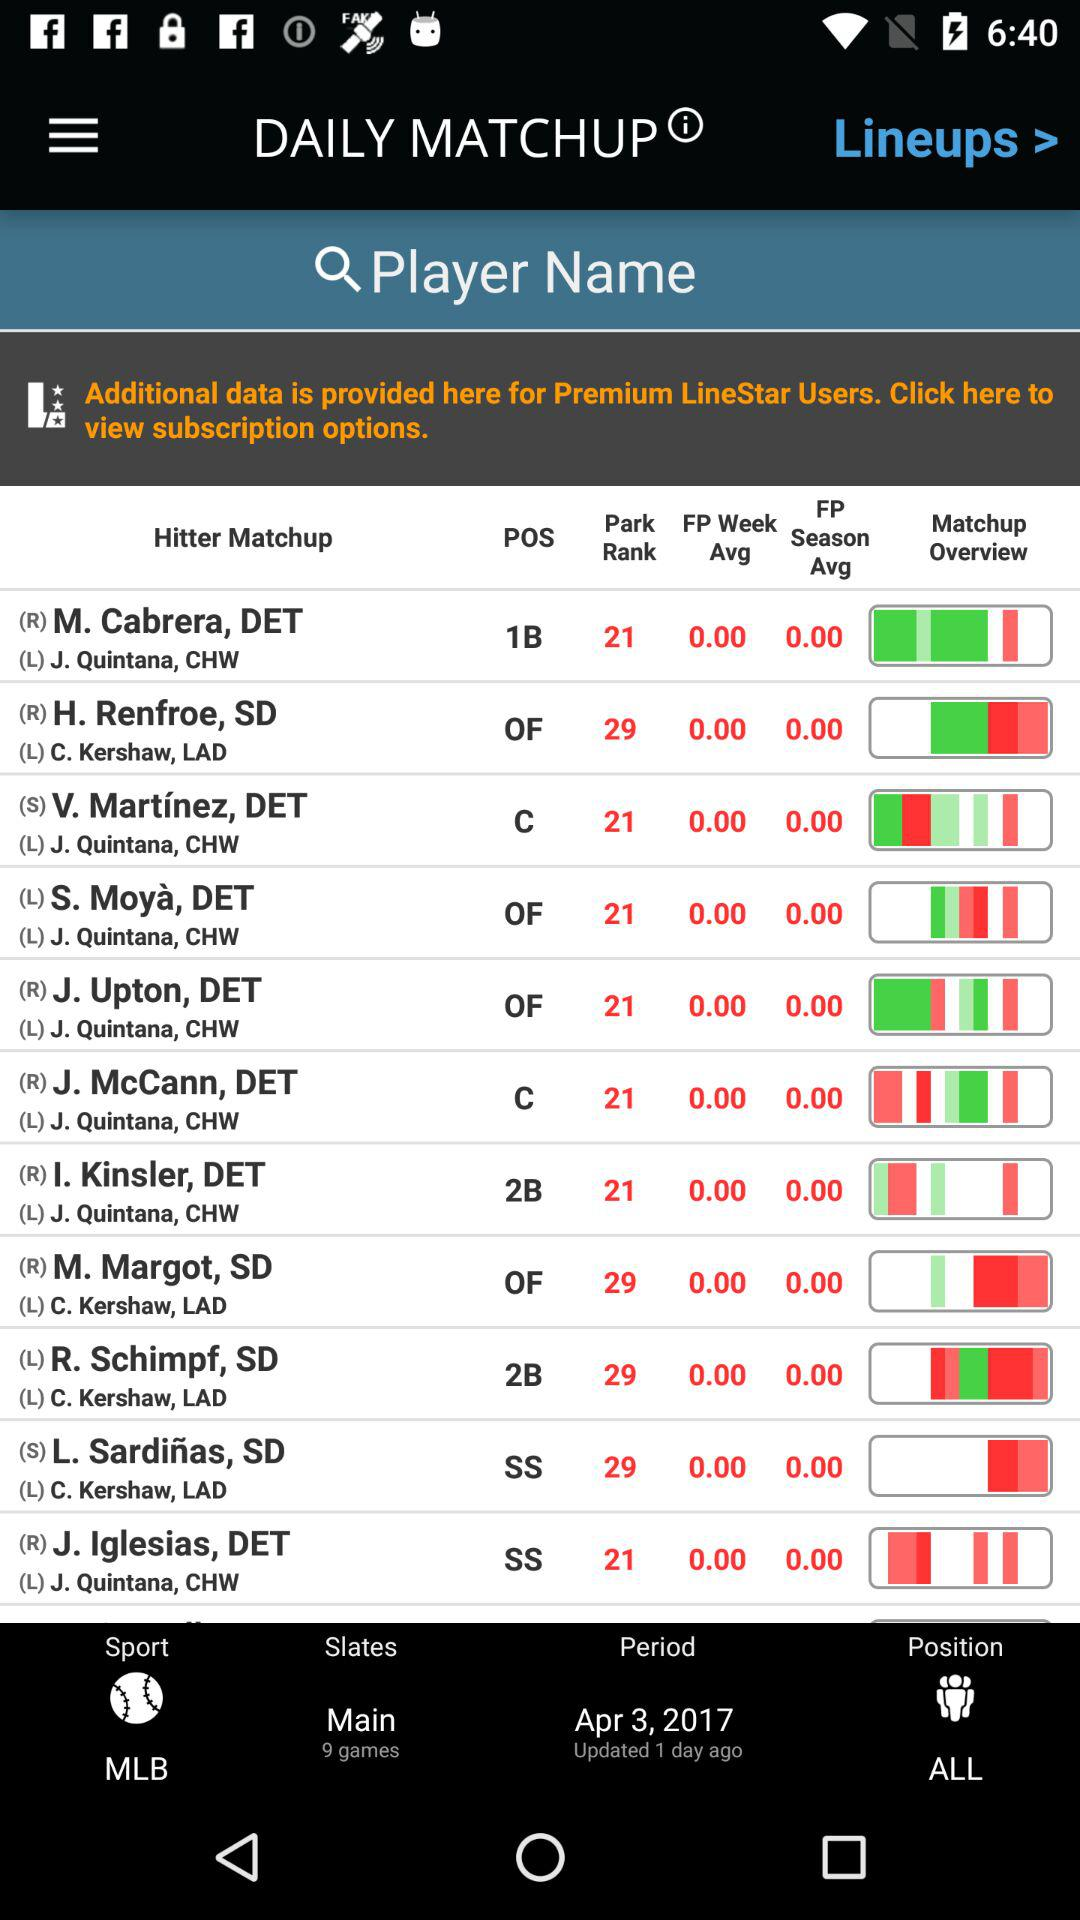Which player has the lowest rank?
When the provided information is insufficient, respond with <no answer>. <no answer> 